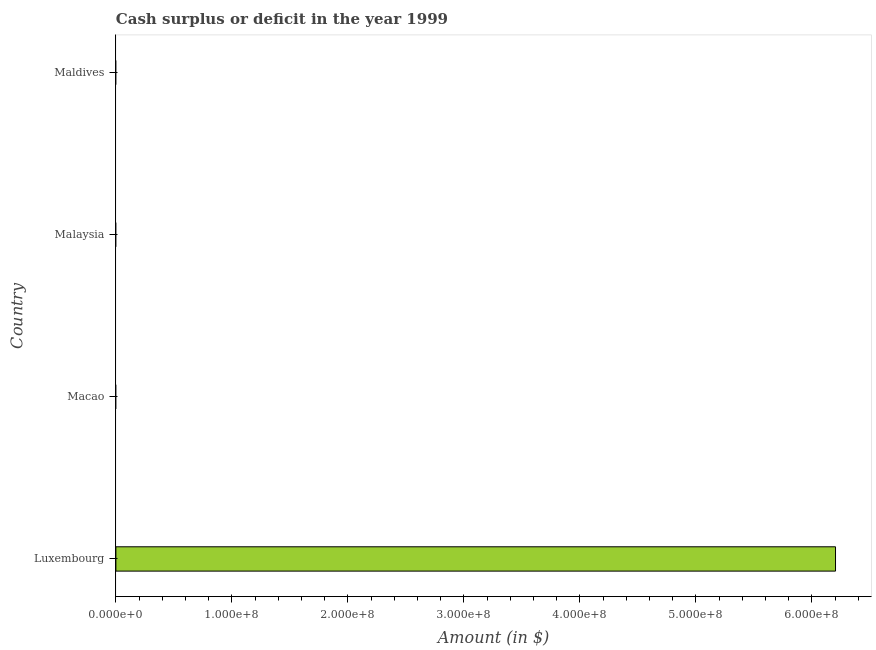Does the graph contain any zero values?
Make the answer very short. Yes. Does the graph contain grids?
Provide a succinct answer. No. What is the title of the graph?
Your response must be concise. Cash surplus or deficit in the year 1999. What is the label or title of the X-axis?
Keep it short and to the point. Amount (in $). What is the label or title of the Y-axis?
Offer a terse response. Country. Across all countries, what is the maximum cash surplus or deficit?
Give a very brief answer. 6.20e+08. In which country was the cash surplus or deficit maximum?
Your response must be concise. Luxembourg. What is the sum of the cash surplus or deficit?
Your answer should be compact. 6.20e+08. What is the average cash surplus or deficit per country?
Make the answer very short. 1.55e+08. In how many countries, is the cash surplus or deficit greater than 360000000 $?
Your answer should be compact. 1. What is the difference between the highest and the lowest cash surplus or deficit?
Make the answer very short. 6.20e+08. In how many countries, is the cash surplus or deficit greater than the average cash surplus or deficit taken over all countries?
Give a very brief answer. 1. Are all the bars in the graph horizontal?
Your response must be concise. Yes. What is the difference between two consecutive major ticks on the X-axis?
Your answer should be very brief. 1.00e+08. What is the Amount (in $) in Luxembourg?
Provide a succinct answer. 6.20e+08. What is the Amount (in $) in Macao?
Provide a succinct answer. 0. What is the Amount (in $) of Maldives?
Your answer should be very brief. 0. 